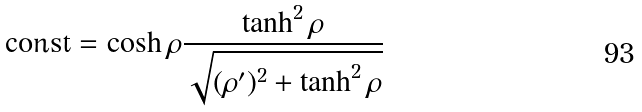<formula> <loc_0><loc_0><loc_500><loc_500>\text {const} = \cosh \rho \frac { \tanh ^ { 2 } { \rho } } { \sqrt { ( \rho ^ { \prime } ) ^ { 2 } + \tanh ^ { 2 } \rho } } \</formula> 